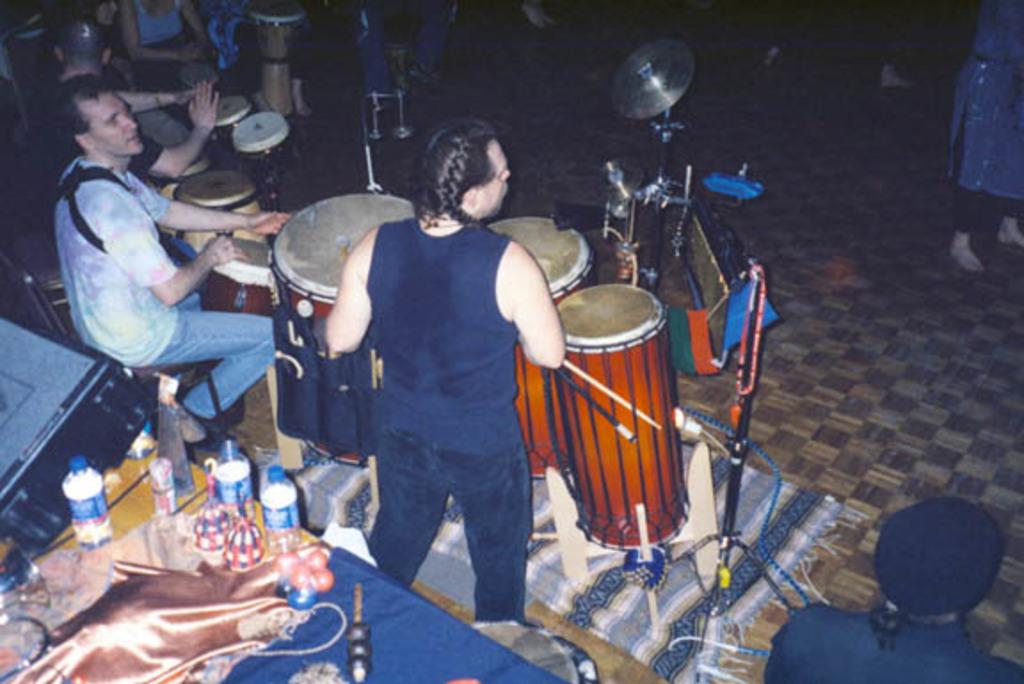What are the people in the image doing? The people in the image are playing drums. What objects are present on the table in the image? There are bottles placed on a table in the image. How many people are in the group shown in the image? The number of people in the group cannot be determined from the provided facts. What type of pin is being used to hold the vessel in place in the image? There is no vessel or pin present in the image; it features a group of people playing drums. 